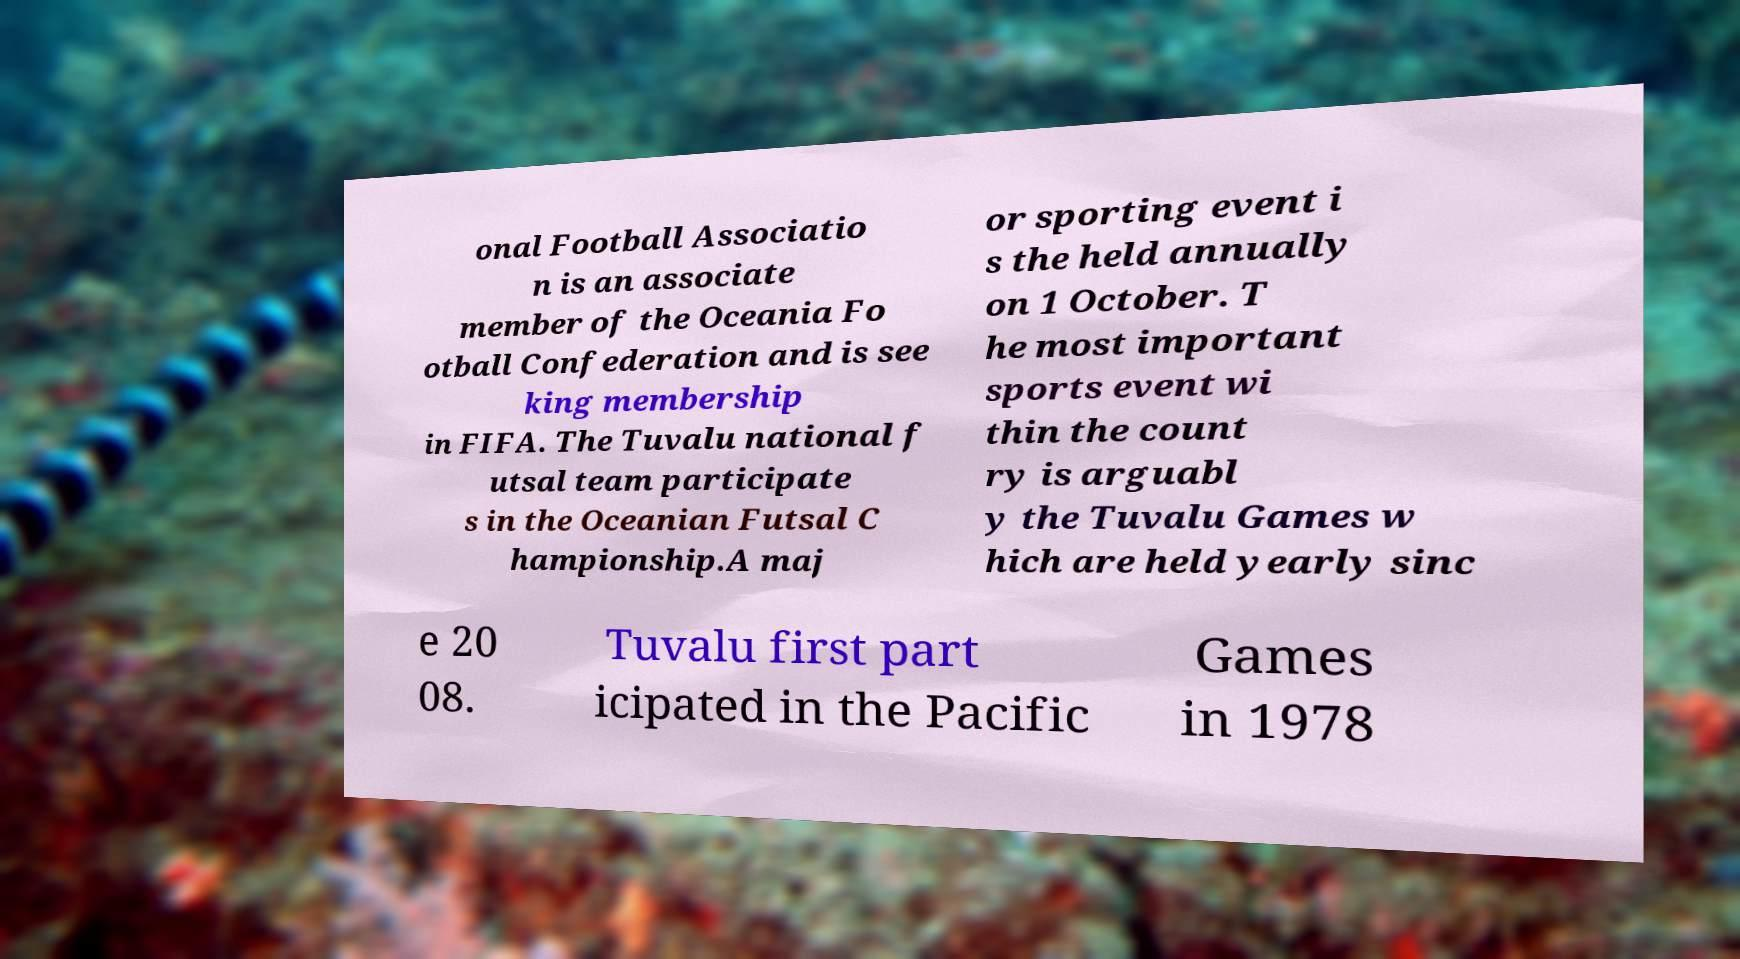Can you accurately transcribe the text from the provided image for me? onal Football Associatio n is an associate member of the Oceania Fo otball Confederation and is see king membership in FIFA. The Tuvalu national f utsal team participate s in the Oceanian Futsal C hampionship.A maj or sporting event i s the held annually on 1 October. T he most important sports event wi thin the count ry is arguabl y the Tuvalu Games w hich are held yearly sinc e 20 08. Tuvalu first part icipated in the Pacific Games in 1978 